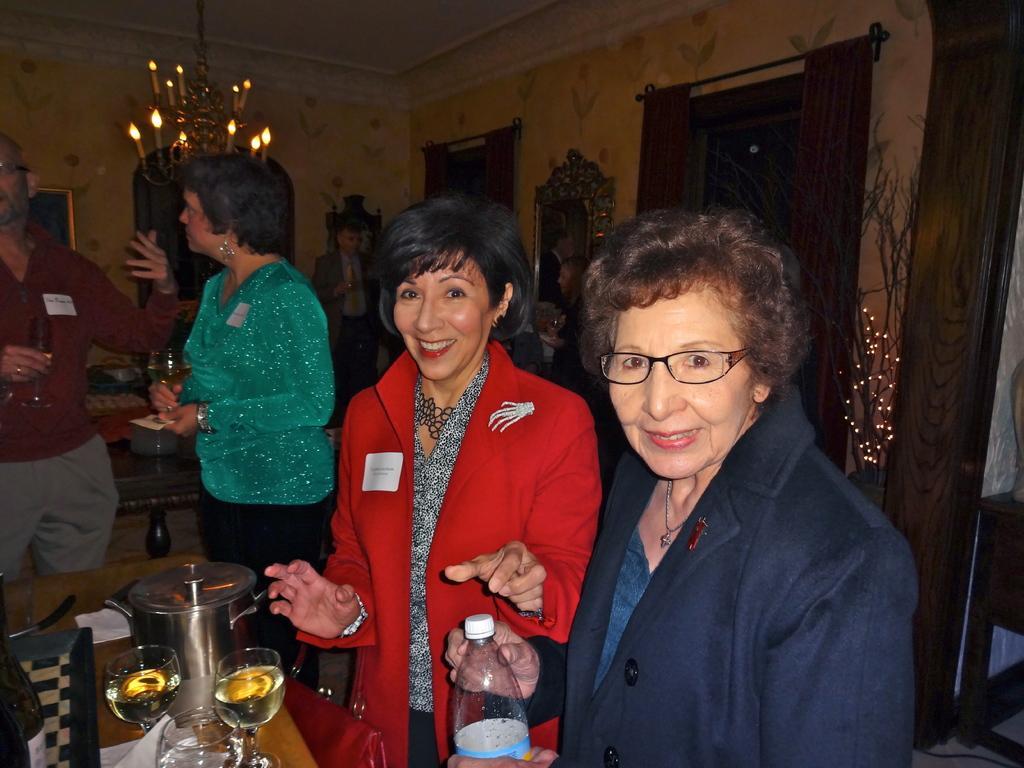How would you summarize this image in a sentence or two? These two women are standing and laughing at here a woman is holding a wine glass and looking into this behind there is a woman and a curtain. 